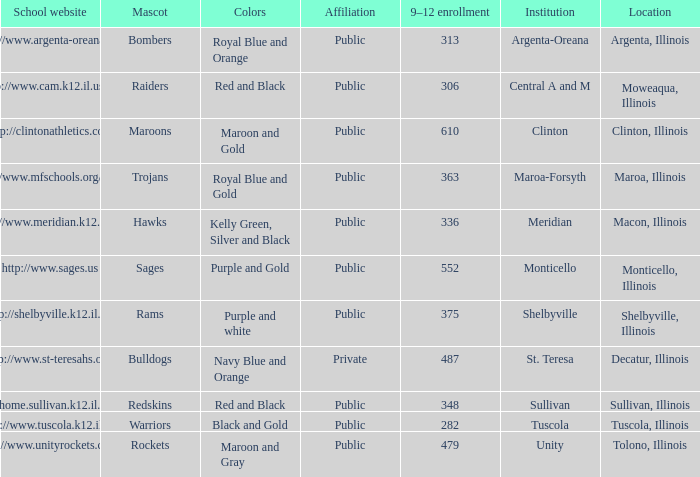Which venue has a total of 363 students in grades 9 to 12? Maroa, Illinois. 